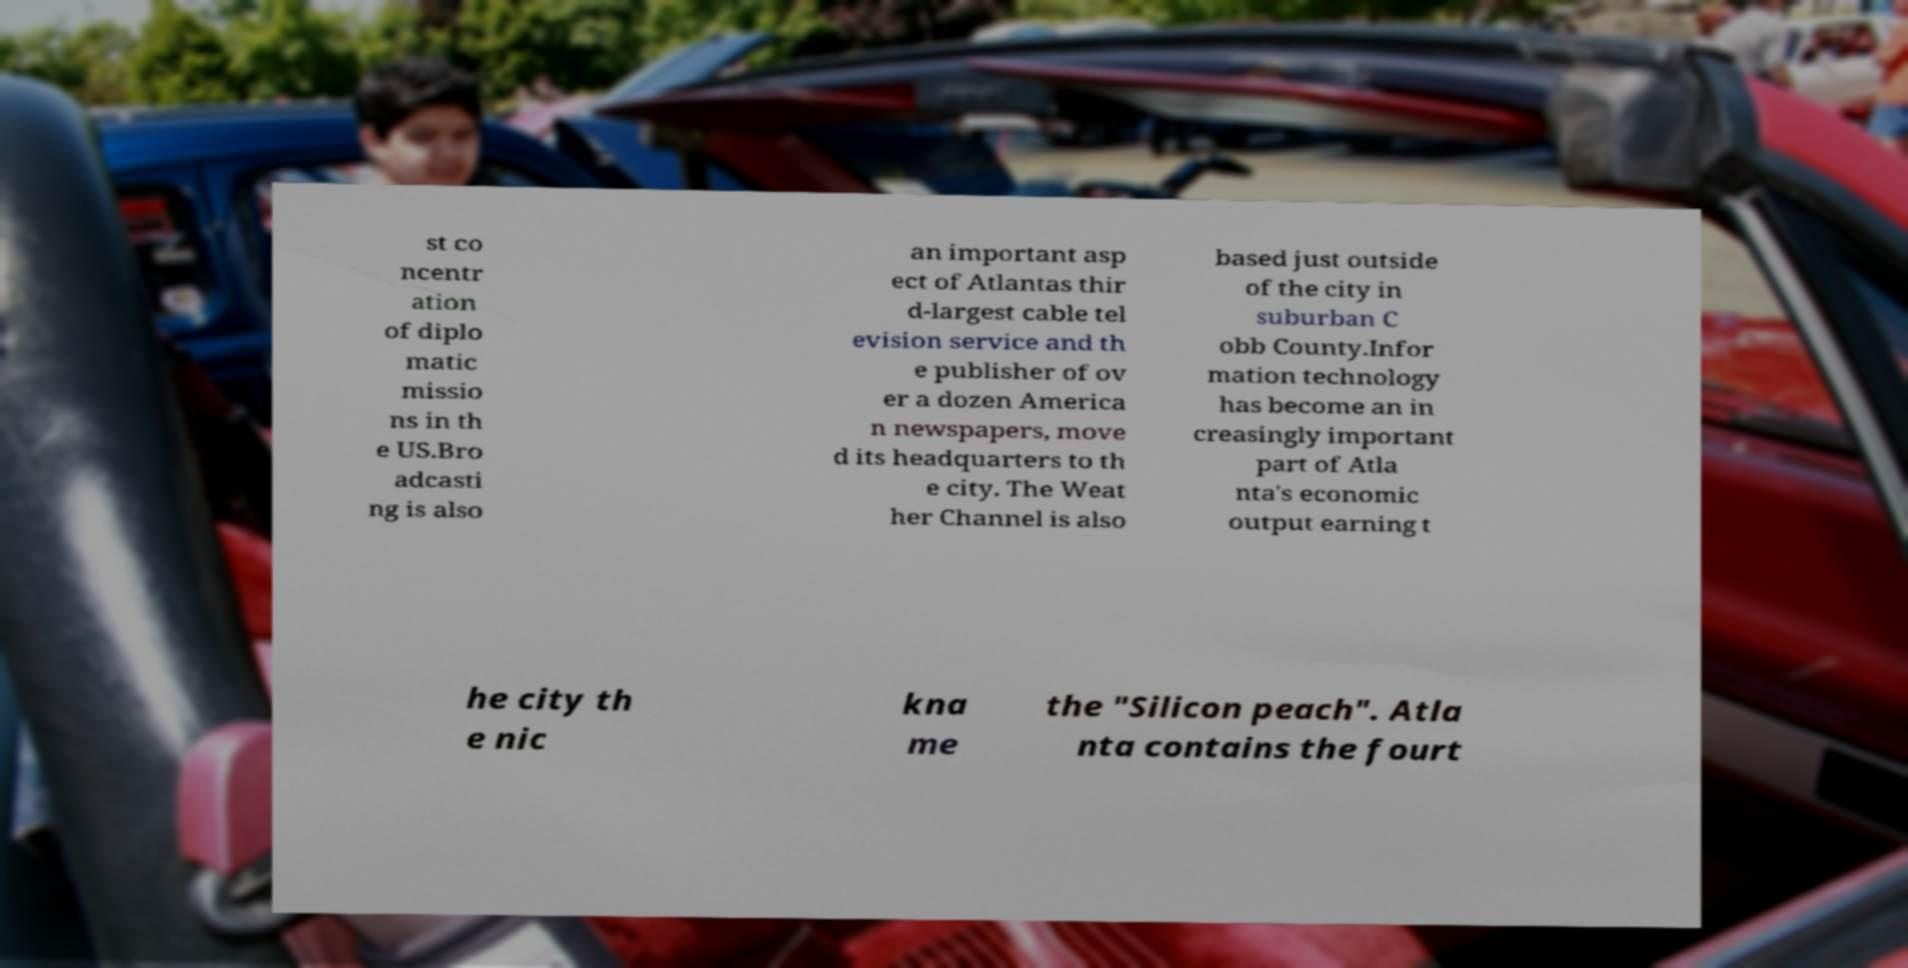Can you accurately transcribe the text from the provided image for me? st co ncentr ation of diplo matic missio ns in th e US.Bro adcasti ng is also an important asp ect of Atlantas thir d-largest cable tel evision service and th e publisher of ov er a dozen America n newspapers, move d its headquarters to th e city. The Weat her Channel is also based just outside of the city in suburban C obb County.Infor mation technology has become an in creasingly important part of Atla nta's economic output earning t he city th e nic kna me the "Silicon peach". Atla nta contains the fourt 